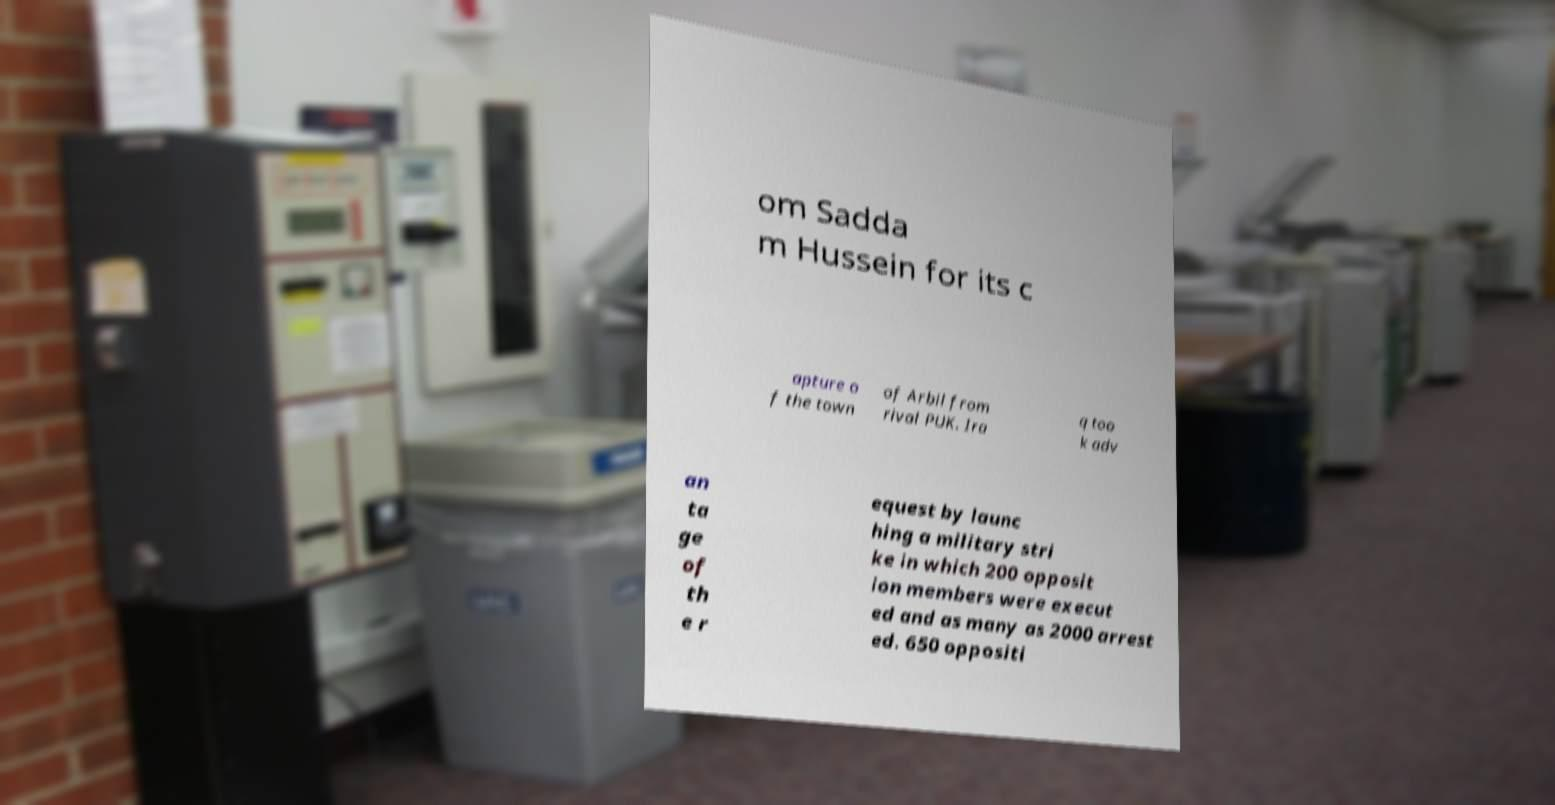There's text embedded in this image that I need extracted. Can you transcribe it verbatim? om Sadda m Hussein for its c apture o f the town of Arbil from rival PUK. Ira q too k adv an ta ge of th e r equest by launc hing a military stri ke in which 200 opposit ion members were execut ed and as many as 2000 arrest ed. 650 oppositi 